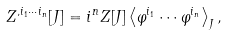<formula> <loc_0><loc_0><loc_500><loc_500>Z ^ { , i _ { 1 } \cdots i _ { n } } [ J ] = i ^ { n } Z [ J ] \left \langle \varphi ^ { i _ { 1 } } \cdots \varphi ^ { i _ { n } } \right \rangle _ { J } ,</formula> 